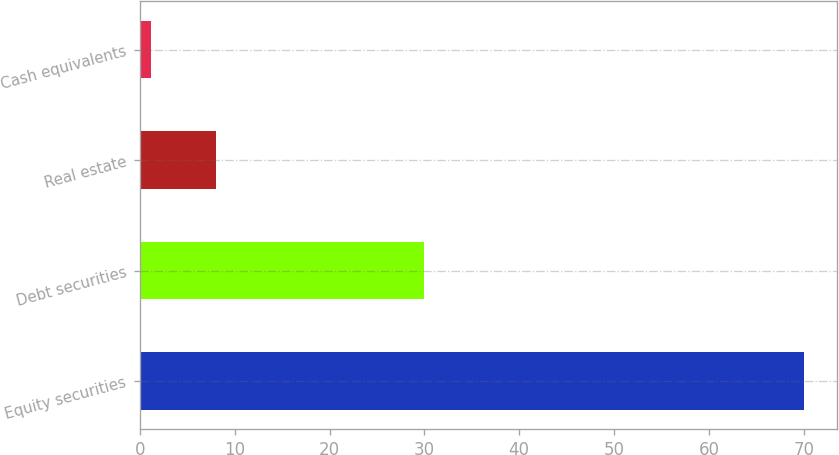<chart> <loc_0><loc_0><loc_500><loc_500><bar_chart><fcel>Equity securities<fcel>Debt securities<fcel>Real estate<fcel>Cash equivalents<nl><fcel>70<fcel>30<fcel>8.07<fcel>1.19<nl></chart> 